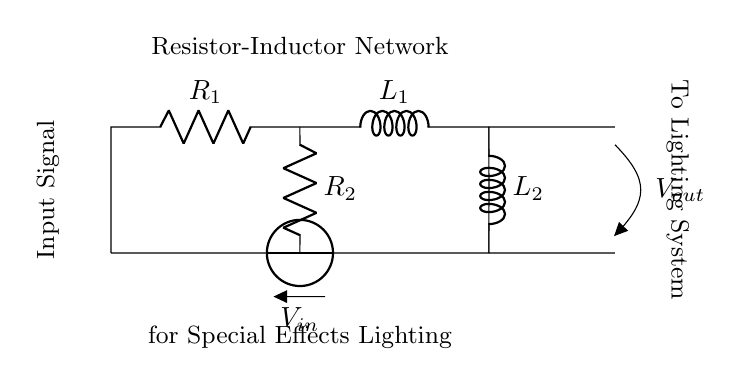What type of components are in this circuit? The circuit includes resistors (R) and inductors (L), as indicated by the labels next to the circuit elements.
Answer: Resistors and inductors What is the voltage source in this circuit? The voltage source is labeled as V_in, which supplies electrical energy to the circuit.
Answer: V_in What is the configuration of R_1 and L_1? R_1 and L_1 are in series, as they are connected in a single path from the voltage source without any branching.
Answer: Series What is the function of R_2 in this circuit? R_2 is part of a parallel branch and its presence likely influences the characteristics such as resistance and overall load in the circuit, impacting the lighting effect.
Answer: Parallel branch resistance How many inductors are present in this circuit? There are two inductors labeled as L_1 and L_2, which are part of the circuit components.
Answer: Two What is the total resistance in the circuit? To determine total resistance, we need to consider R_1 and R_2 together. Since R_1 is in series with R_2 (which is parallel to L_2), the effective resistance can be calculated using the formula for parallel and series combinations, however, specific values are not provided here.
Answer: Combination of R and L resistances What could be the usage of this circuit in cinema projection systems? This circuit, comprising resistors and inductors, could be used for controlling lighting effects, enabling different brightness levels or special effects needed during projection.
Answer: Special effects lighting 